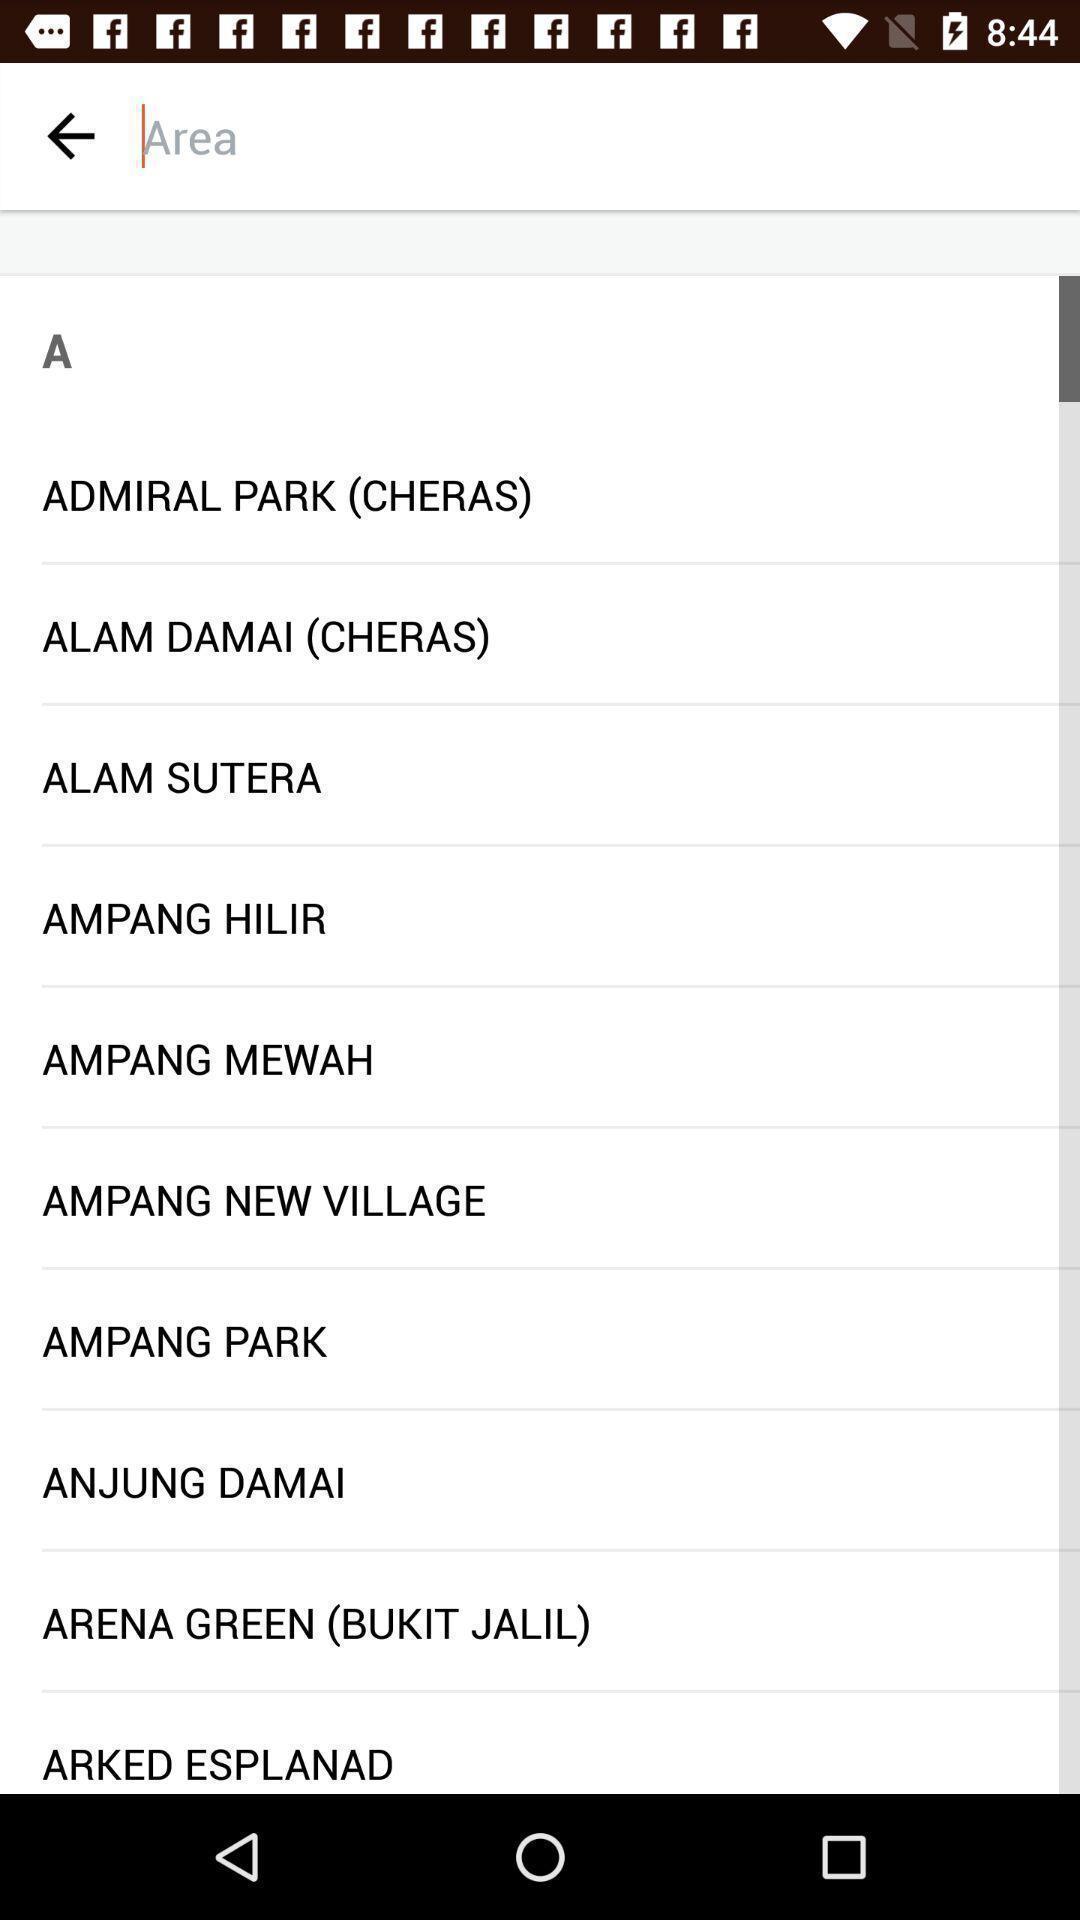Explain what's happening in this screen capture. Screen showing search bar to find area. 